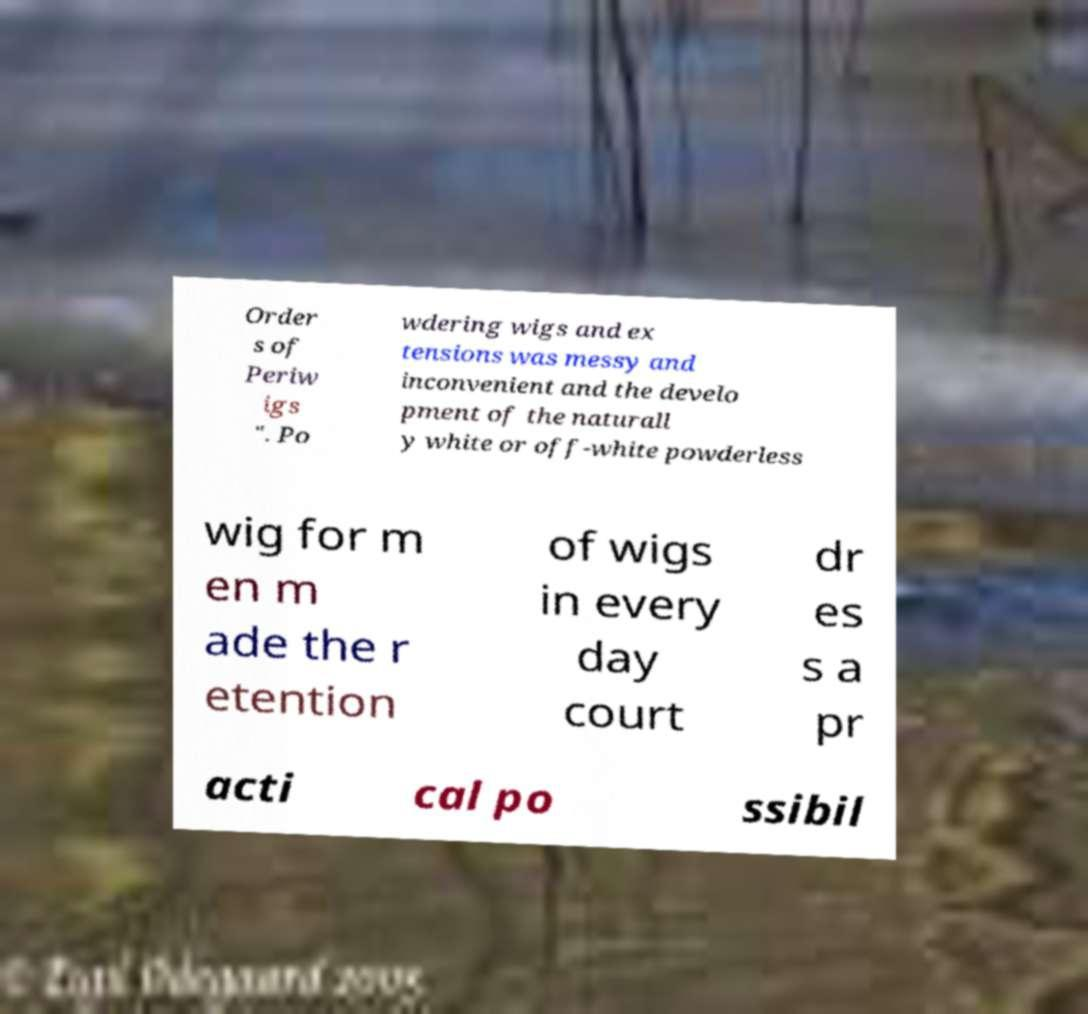Please identify and transcribe the text found in this image. Order s of Periw igs ". Po wdering wigs and ex tensions was messy and inconvenient and the develo pment of the naturall y white or off-white powderless wig for m en m ade the r etention of wigs in every day court dr es s a pr acti cal po ssibil 